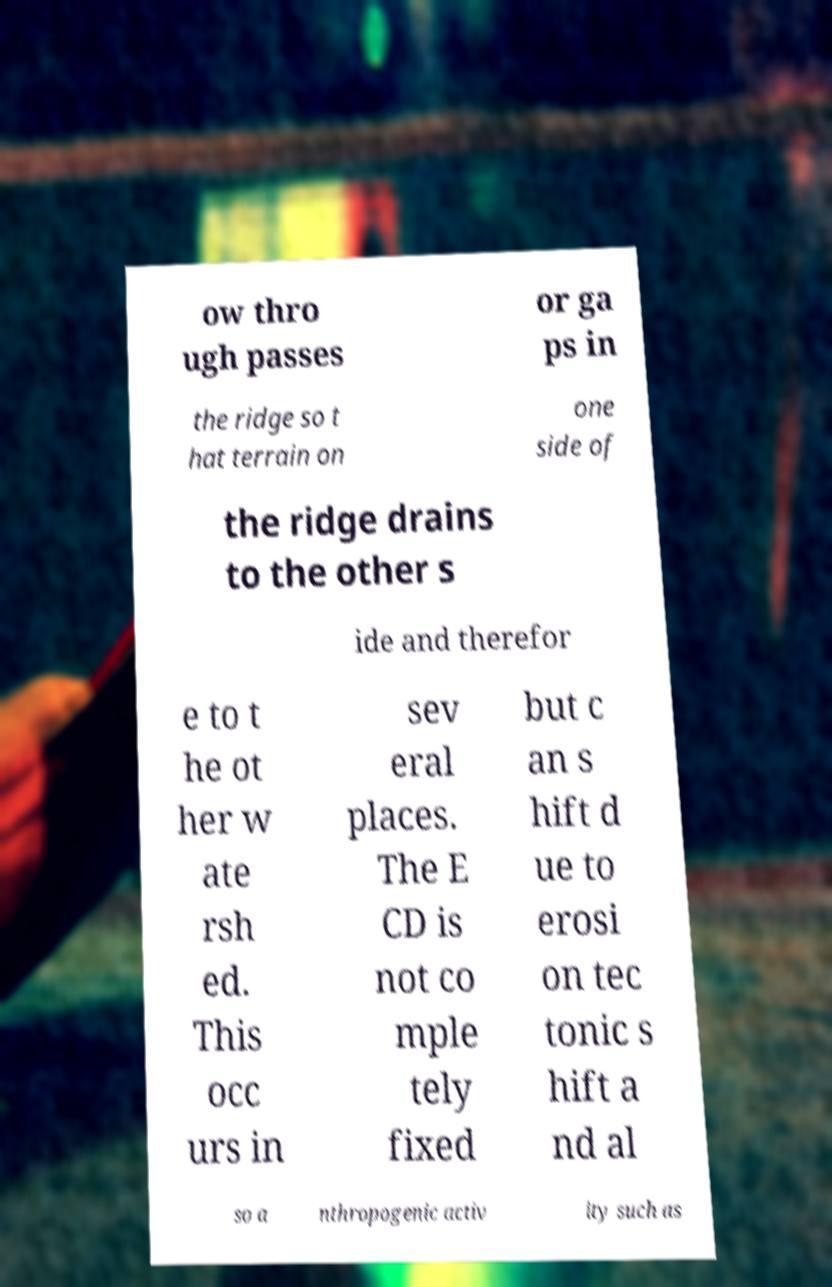Could you assist in decoding the text presented in this image and type it out clearly? ow thro ugh passes or ga ps in the ridge so t hat terrain on one side of the ridge drains to the other s ide and therefor e to t he ot her w ate rsh ed. This occ urs in sev eral places. The E CD is not co mple tely fixed but c an s hift d ue to erosi on tec tonic s hift a nd al so a nthropogenic activ ity such as 